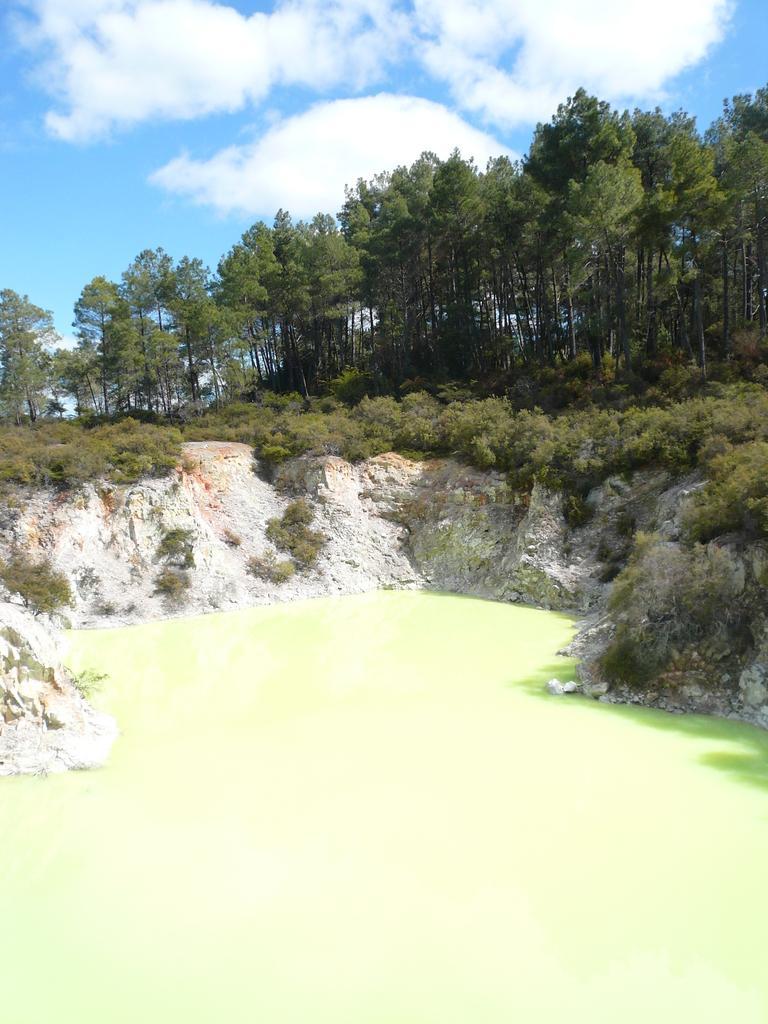Please provide a concise description of this image. This is an outside view. At the bottom, I can see the water. In the middle of the image there are trees and also I can see a rock. At the top of the image I can see the sky and clouds. 